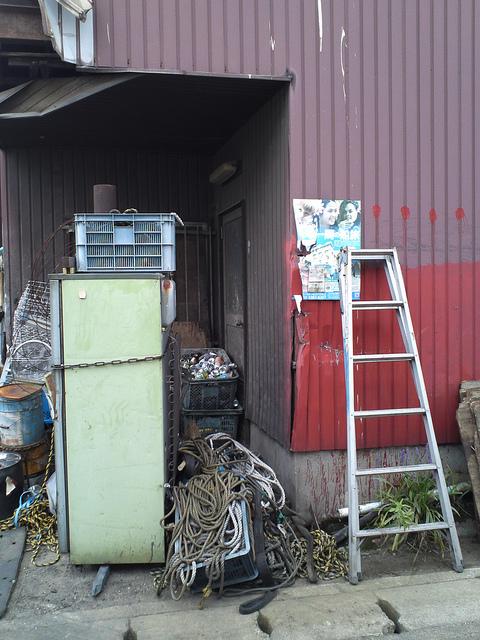What color is the building?
Be succinct. Red. Is this a junkyard?
Answer briefly. Yes. What is the garbage doing on this sidewalk?
Concise answer only. Sitting. Is this an old style air conditioner?
Be succinct. No. What is the large light green appliance?
Give a very brief answer. Fridge. What kind of structure is that?
Quick response, please. Barn. How many pots are there?
Quick response, please. 0. Why isn't someone getting rid of all this junk?
Give a very brief answer. Hoarder. 